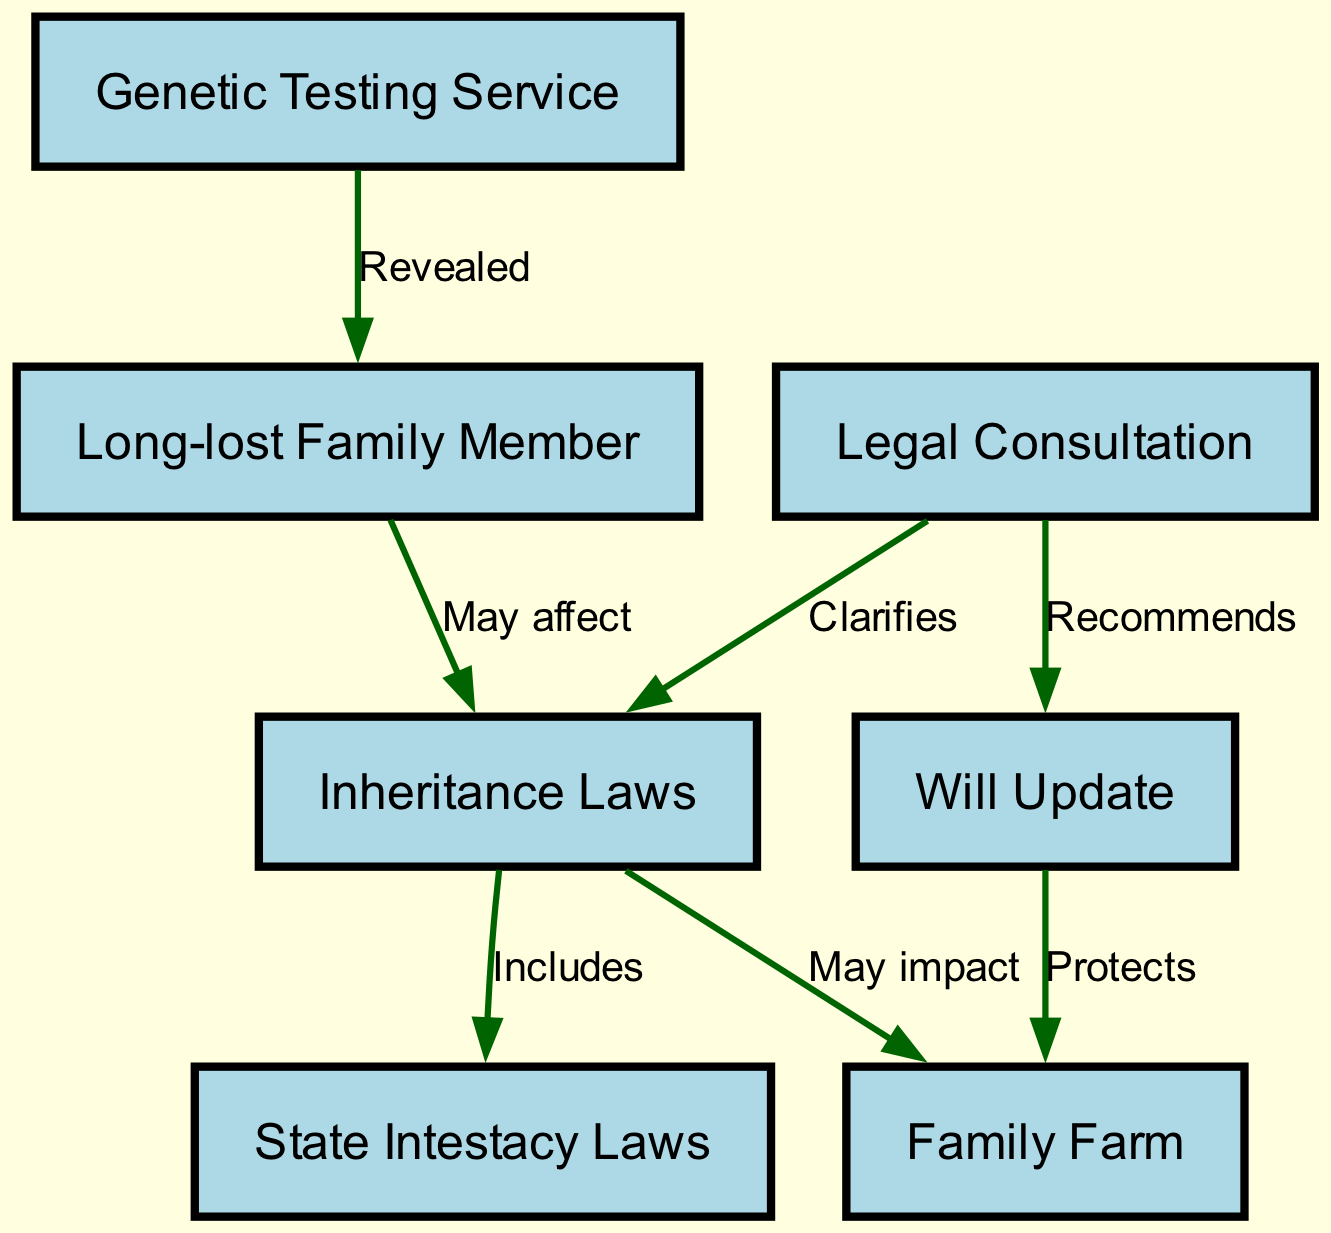What does the genetic testing service reveal? The diagram indicates that the genetic testing service reveals a long-lost family member.
Answer: Long-lost family member How many nodes are present in the diagram? By counting the listed nodes in the diagram, there are a total of seven distinct nodes representing different concepts.
Answer: Seven What may the inheritance laws affect? According to the diagram, the inheritance laws may affect the family farm, indicating a potential impact on familial assets.
Answer: Family farm Which law includes state intestacy laws? The diagram shows that the inheritance laws include state intestacy laws, clarifying the legal framework related to inheritance.
Answer: Inheritance laws What does legal consultation clarify? The legal consultation clarifies inheritance laws according to the relationships depicted in the diagram, indicating a focus on legal understanding.
Answer: Inheritance laws What does updating the will protect? The diagram indicates that updating the will protects the family farm, suggesting that proper legal measures are needed to secure family assets.
Answer: Family farm How many edges are in the diagram? Counting the directed connections between nodes in the diagram reveals there are a total of six edges indicating relationships.
Answer: Six What recommendation is made by legal consultation? The diagram shows that the legal consultation recommends a will update, highlighting the importance of keeping legal documents current.
Answer: Will update What relationship exists between the long-lost family member and inheritance laws? The diagram illustrates that there is a relationship where discovering a long-lost family member may affect inheritance laws, suggesting implications for estate distribution.
Answer: May affect 